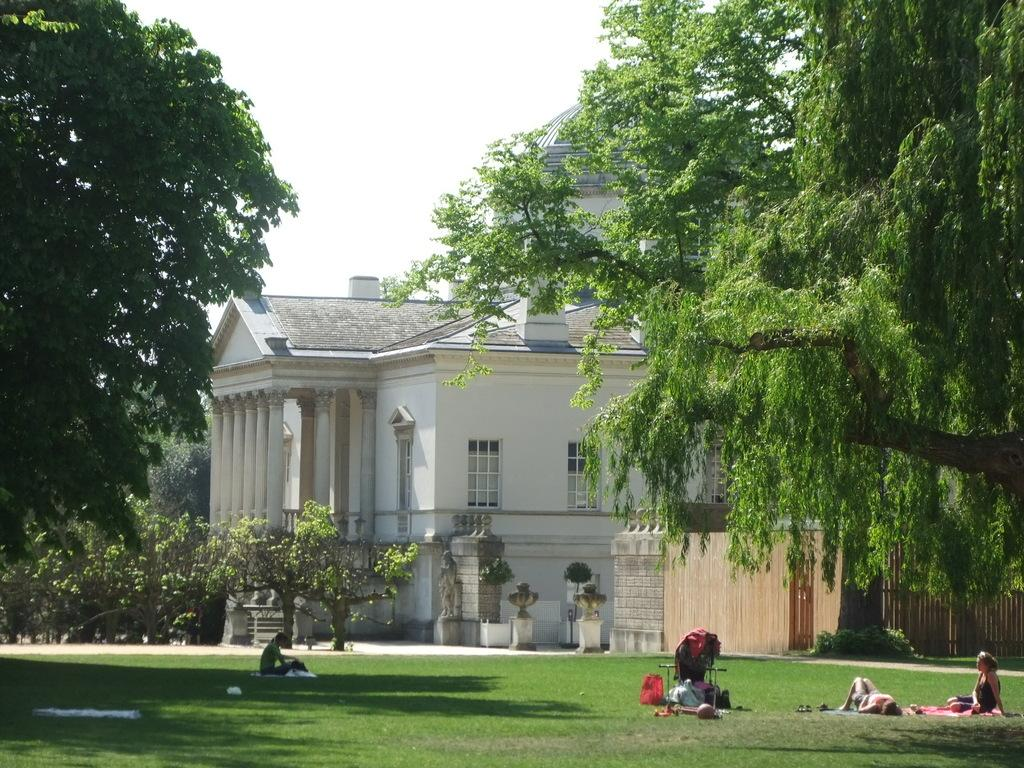How many people are in the image? There is a group of persons in the image. What are the persons in the image doing? The persons are resting on the ground. What type of surface are they resting on? The ground has a lawn. What can be seen in the background of the image? There are trees and a building in the background of the image. What is the condition of the sky in the image? The sky is clear and visible in the background of the image. What type of treatment is being administered to the middle nerve in the image? There is no mention of any medical treatment or nerves in the image; it features a group of persons resting on a lawn. 